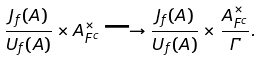Convert formula to latex. <formula><loc_0><loc_0><loc_500><loc_500>\frac { J _ { f } ( A ) } { U _ { f } ( A ) } \times A ^ { \times } _ { F ^ { c } } \longrightarrow \frac { J _ { f } ( A ) } { U _ { f } ( A ) } \times \frac { A ^ { \times } _ { F ^ { c } } } { \Gamma } .</formula> 